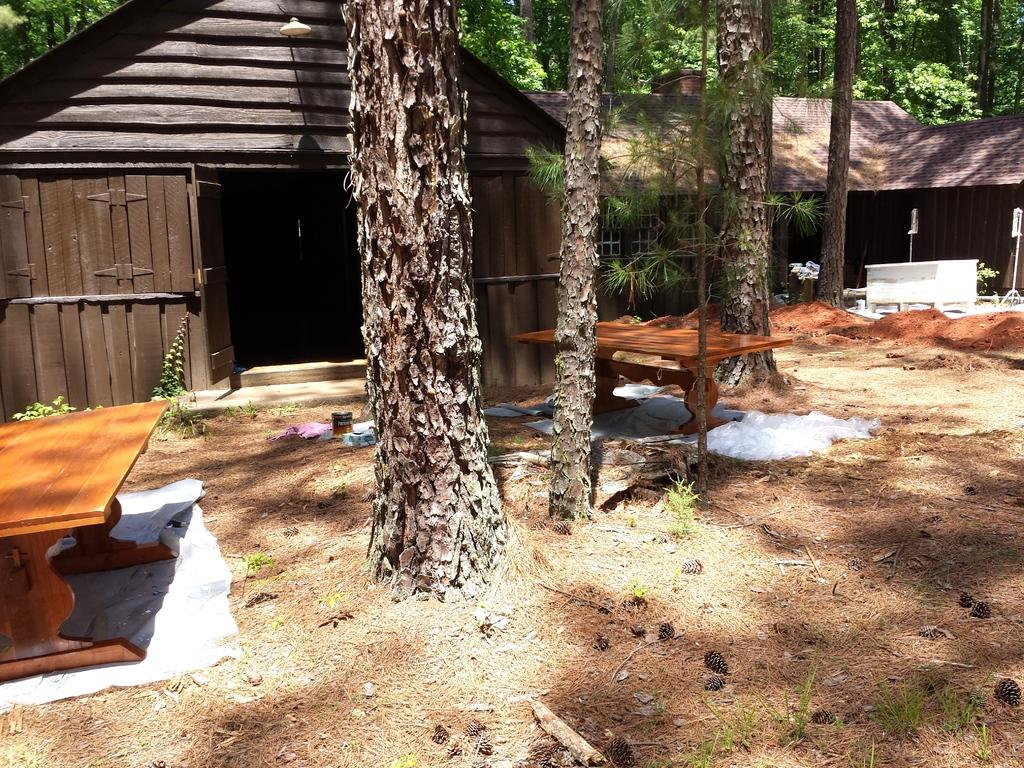What type of structure is visible in the image? There is a house in the image. What natural elements can be seen in the image? There are many trees in the image. How many tables are present in the image? There are two tables in the image. What color is the blood on the floor in the image? There is no blood present in the image; it only features a house, trees, and tables. 